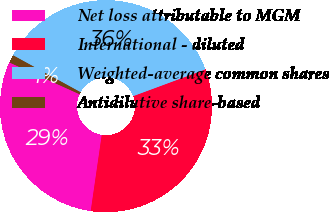Convert chart to OTSL. <chart><loc_0><loc_0><loc_500><loc_500><pie_chart><fcel>Net loss attributable to MGM<fcel>International - diluted<fcel>Weighted-average common shares<fcel>Antidilutive share-based<nl><fcel>29.48%<fcel>32.93%<fcel>36.39%<fcel>1.2%<nl></chart> 